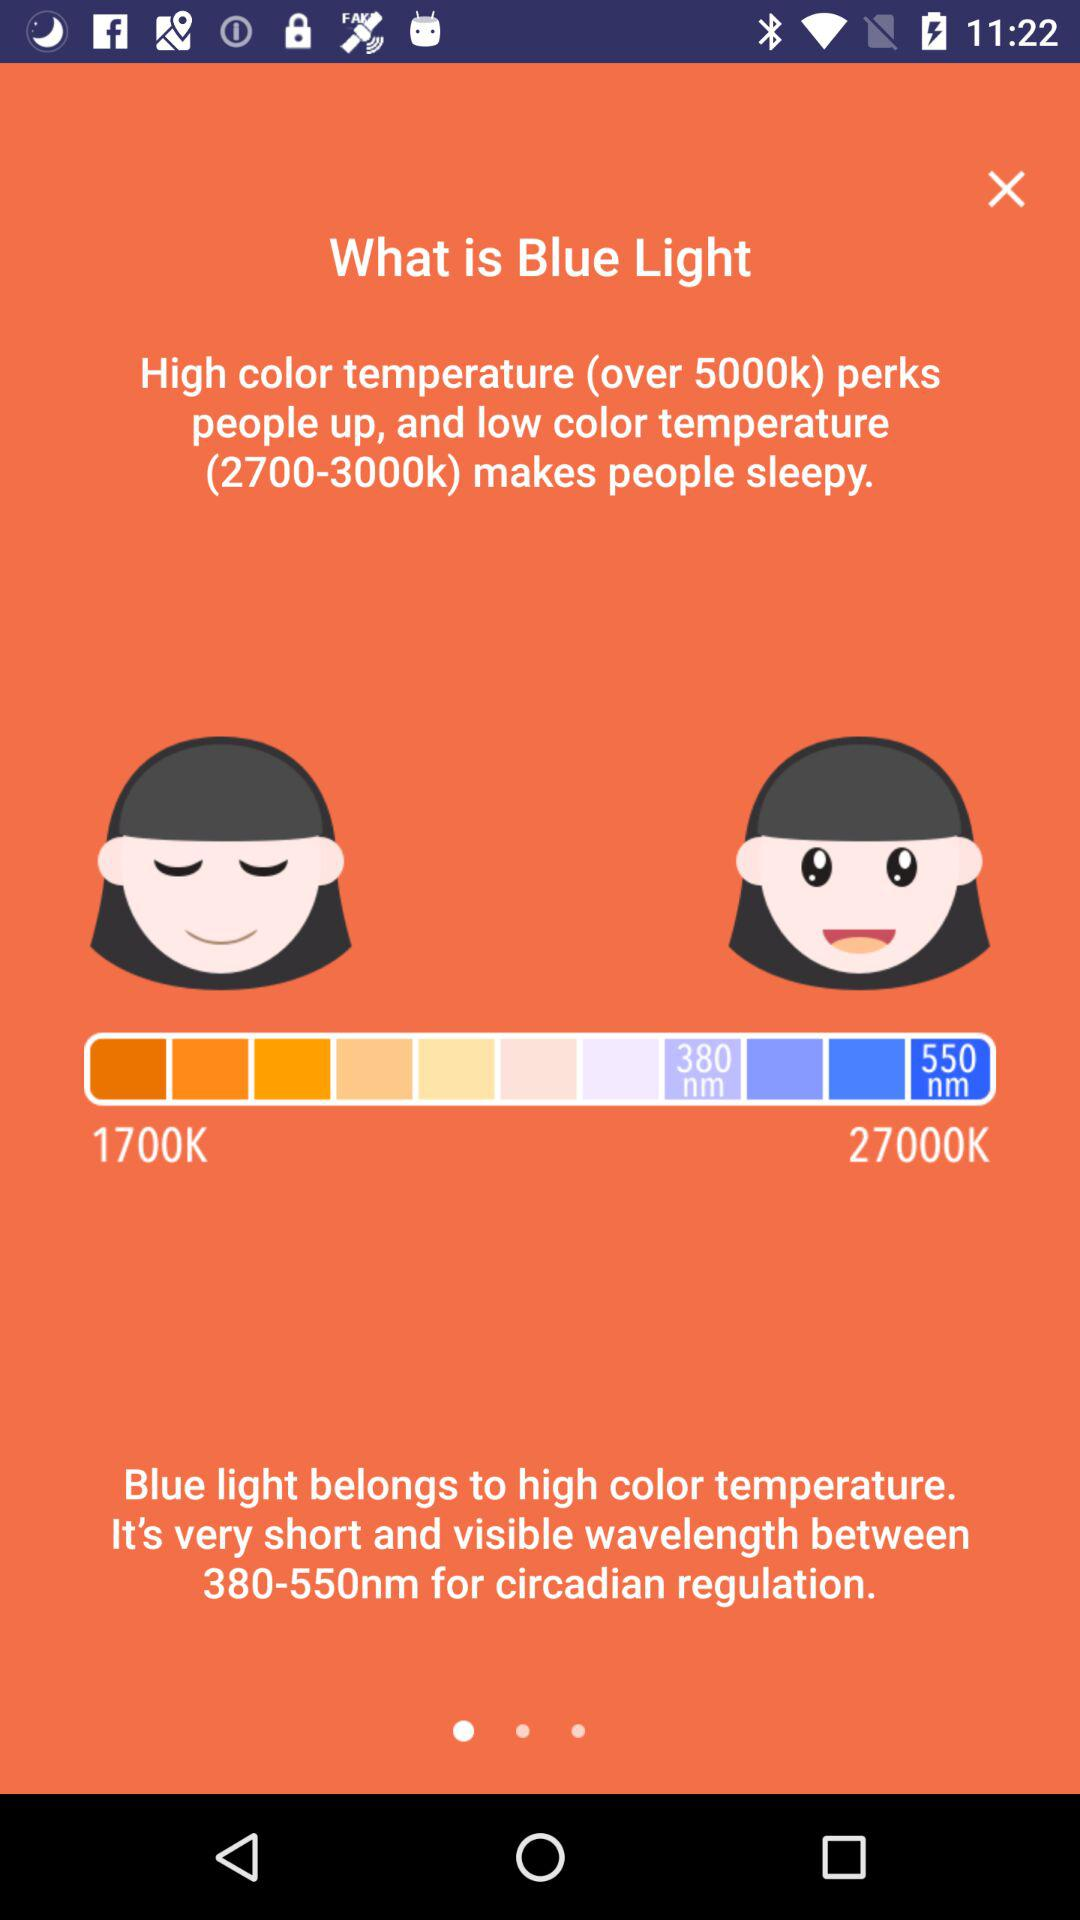What is the range of the wavelength? The range of the wavelength is 380-550 nm. 